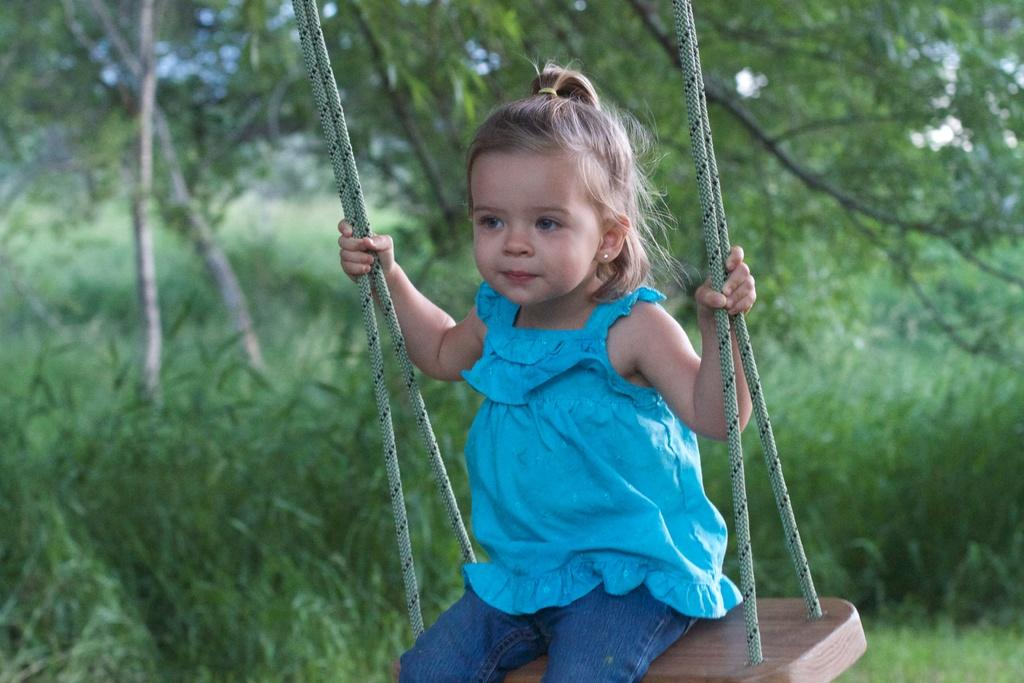What is the main subject of the image? There is a baby in the image. What is the baby wearing? The baby is wearing a blue top and jeans. Where is the baby sitting? The baby is sitting on a swing. What can be seen in the background of the image? There are trees and plants in the background of the image. Is there a fireman present in the image, helping the baby on the swing? No, there is no fireman present in the image. The baby is simply sitting on a swing, and the image does not depict any interaction with a fireman. 